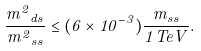<formula> <loc_0><loc_0><loc_500><loc_500>\frac { { m ^ { 2 } } _ { d s } } { { m ^ { 2 } } _ { s s } } \leq ( 6 \times 1 0 ^ { - 3 } ) \frac { m _ { s s } } { 1 { T e V } } .</formula> 